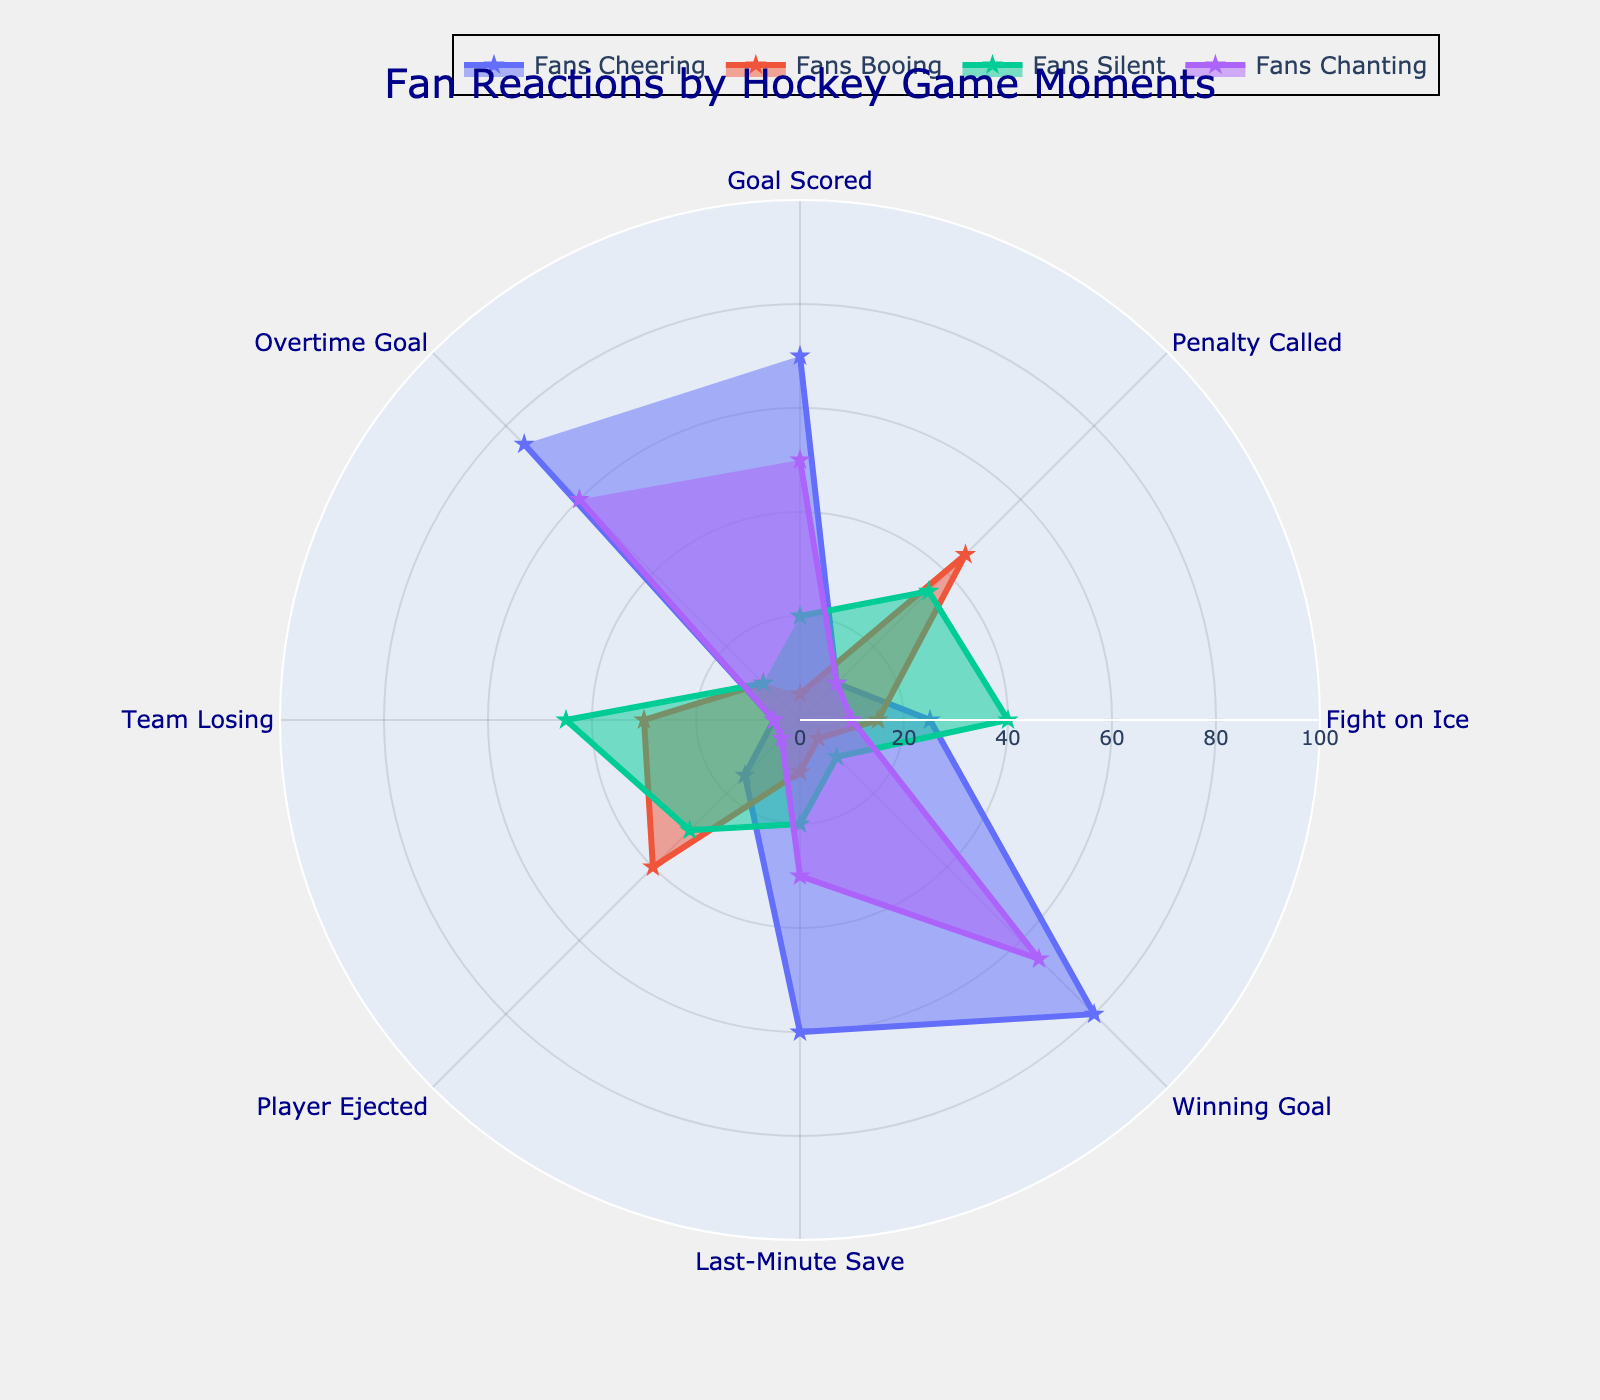What is the title of the figure? The title of the figure is typically placed at the top center of the chart. Here, it clearly states the purpose of the chart.
Answer: "Fan Reactions by Hockey Game Moments" What moment has the highest percentage of fans cheering? To answer this, look at the trace labeled 'Fans Cheering' and identify the moment with the highest radial value in the polar chart. The highest point corresponds to the 'Winning Goal' moment.
Answer: Winning Goal How many moments have at least 40% fans booing? Observe the trace labeled 'Fans Booing' and count the number of moments where the radial value is 40 or more. These are 'Penalty Called' (45), 'Player Ejected' (40), and 'Team Losing' (30 does not meet the criteria). Thus, only two moments meet this condition.
Answer: 2 What fan reaction is most prevalent when a goal is scored? For 'Goal Scored', compare the values of all reactions. The highest value indicates the most prevalent reaction. Here, the highest value is for 'Fans Cheering' (70).
Answer: Fans Cheering Which game moment has the least percentage of fans chanting? Look at the trace labeled 'Fans Chanting' and identify the moment with the lowest radial value. The moment with the lowest value is 'Player Ejected' with 5%.
Answer: Player Ejected Among 'Goal Scored' and 'Overtime Goal', which has more fans silent? Compare the 'Fans Silent' values for 'Goal Scored' and 'Overtime Goal'. 'Goal Scored' has 20% while 'Overtime Goal' has 10%. Therefore, 'Goal Scored' has more fans silent.
Answer: Goal Scored For the 'Last-Minute Save' moment, what's the total percentage of fans either cheering or booing? Add the percentages of 'Fans Cheering' (60) and 'Fans Booing' (10) for the 'Last-Minute Save' moment. The sum is 60 + 10 = 70.
Answer: 70 What is the average percentage of fans silent across all moments? To find the average, add up all values under 'Fans Silent' (20 + 35 + 40 + 10 + 20 + 30 + 45 + 10) and divide by the total number of moments (8). This results in 210 / 8 = 26.25.
Answer: 26.25 Which fan reaction shows a sudden drop in percentage from 'Winning Goal' to 'Player Ejected'? Compare the values for each reaction between 'Winning Goal' and 'Player Ejected'. 'Winning Goal' has 80% cheering and 'Player Ejected' has 15%, showing a significant drop of 65%.
Answer: Fans Cheering 